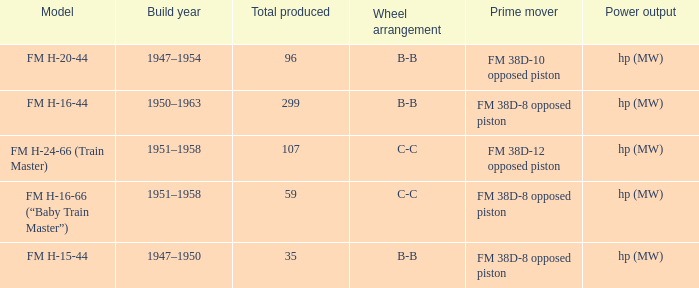Which is the smallest Total produced with a model of FM H-15-44? 35.0. 